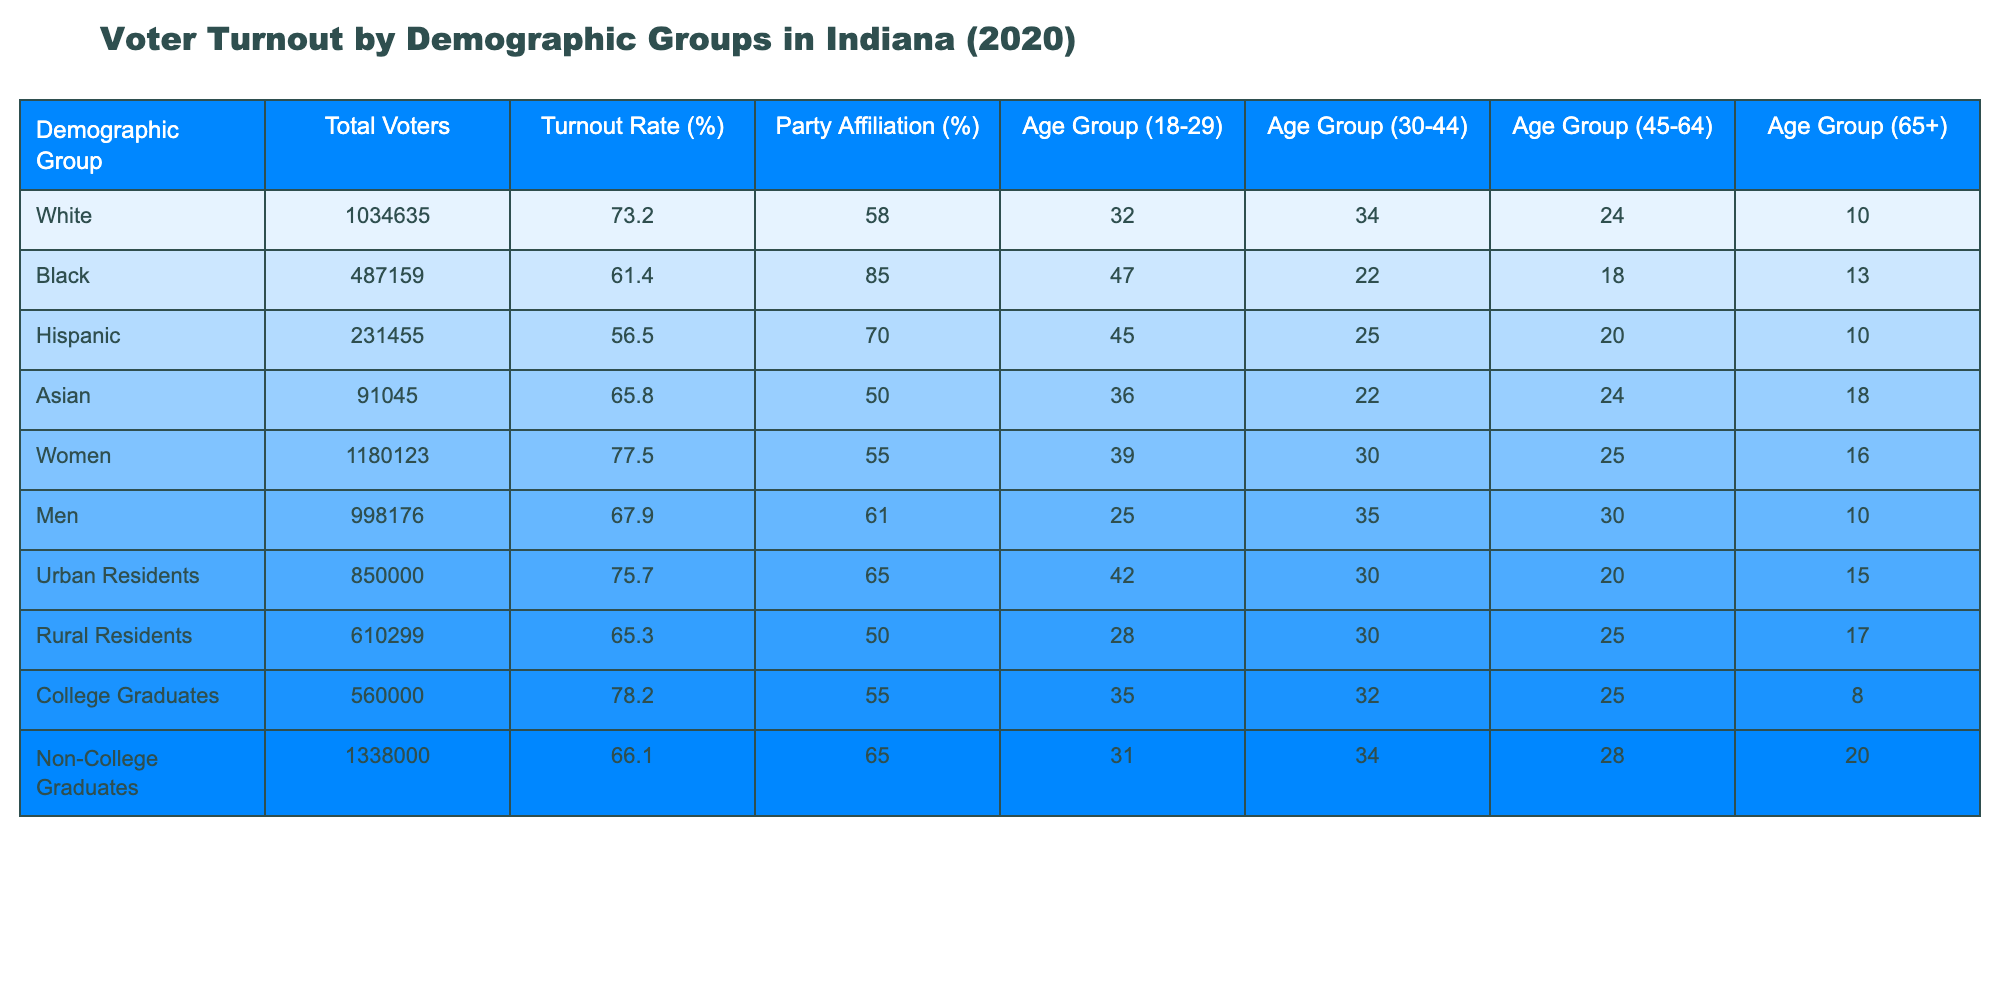What is the voter turnout rate for Black individuals in Indiana? The turnout rate for the Black demographic group is directly listed in the table as 61.4%.
Answer: 61.4% Which demographic group had the highest turnout rate? The table shows that the Women demographic group has the highest turnout rate at 77.5%.
Answer: Women What is the difference in voter turnout rates between college graduates and non-college graduates? The voter turnout rate for college graduates is 78.2% and for non-college graduates, it is 66.1%. The difference is calculated as 78.2% - 66.1% = 12.1%.
Answer: 12.1% Do more Urban Residents or Rural Residents participate in voting? The table specifies that Urban Residents have a turnout rate of 75.7%, whereas Rural Residents have a turnout rate of 65.3%. Therefore, more Urban Residents participate in voting.
Answer: Yes What is the average voter turnout rate for the age group 18-29 across all demographic groups? The voter turnout for the 18-29 age group can be calculated by finding the values for each demographic: White (10), Black (13), Hispanic (10), Asian (18), Women (16), Men (10), Urban (15), Rural (17). Adding these gives 10 + 13 + 10 + 18 + 16 + 10 + 15 + 17 = 119. Dividing by the number of demographic groups (8) results in an average of 119 / 8 = 14.875%.
Answer: 14.875% Which demographic group has the lowest turnout rate? The table indicates that the Hispanic demographic group has the lowest turnout rate at 56.5%.
Answer: Hispanic 